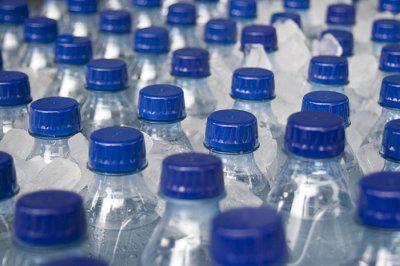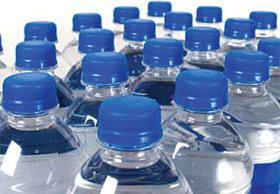The first image is the image on the left, the second image is the image on the right. Assess this claim about the two images: "There are three bottles in one of the images.". Correct or not? Answer yes or no. No. 